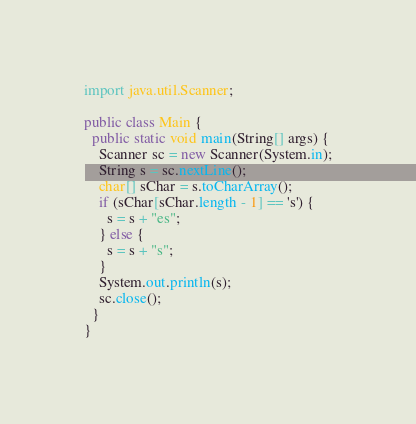Convert code to text. <code><loc_0><loc_0><loc_500><loc_500><_Java_>import java.util.Scanner;

public class Main {
  public static void main(String[] args) {
    Scanner sc = new Scanner(System.in);
    String s = sc.nextLine();
    char[] sChar = s.toCharArray();
    if (sChar[sChar.length - 1] == 's') {
      s = s + "es";
    } else {
      s = s + "s";
    }
    System.out.println(s);
    sc.close();
  }
}</code> 